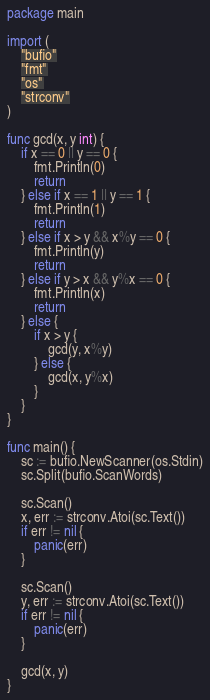Convert code to text. <code><loc_0><loc_0><loc_500><loc_500><_Go_>package main

import (
	"bufio"
	"fmt"
	"os"
	"strconv"
)

func gcd(x, y int) {
	if x == 0 || y == 0 {
		fmt.Println(0)
		return
	} else if x == 1 || y == 1 {
		fmt.Println(1)
		return
	} else if x > y && x%y == 0 {
		fmt.Println(y)
		return
	} else if y > x && y%x == 0 {
		fmt.Println(x)
		return
	} else {
		if x > y {
			gcd(y, x%y)
		} else {
			gcd(x, y%x)
		}
	}
}

func main() {
	sc := bufio.NewScanner(os.Stdin)
	sc.Split(bufio.ScanWords)

	sc.Scan()
	x, err := strconv.Atoi(sc.Text())
	if err != nil {
		panic(err)
	}

	sc.Scan()
	y, err := strconv.Atoi(sc.Text())
	if err != nil {
		panic(err)
	}

	gcd(x, y)
}

</code> 